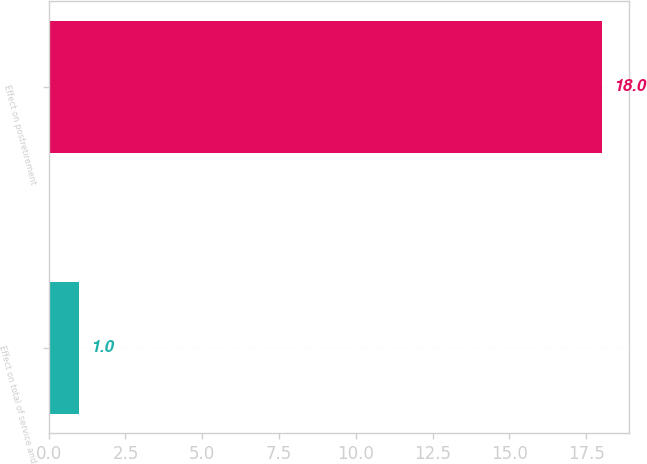Convert chart to OTSL. <chart><loc_0><loc_0><loc_500><loc_500><bar_chart><fcel>Effect on total of service and<fcel>Effect on postretirement<nl><fcel>1<fcel>18<nl></chart> 